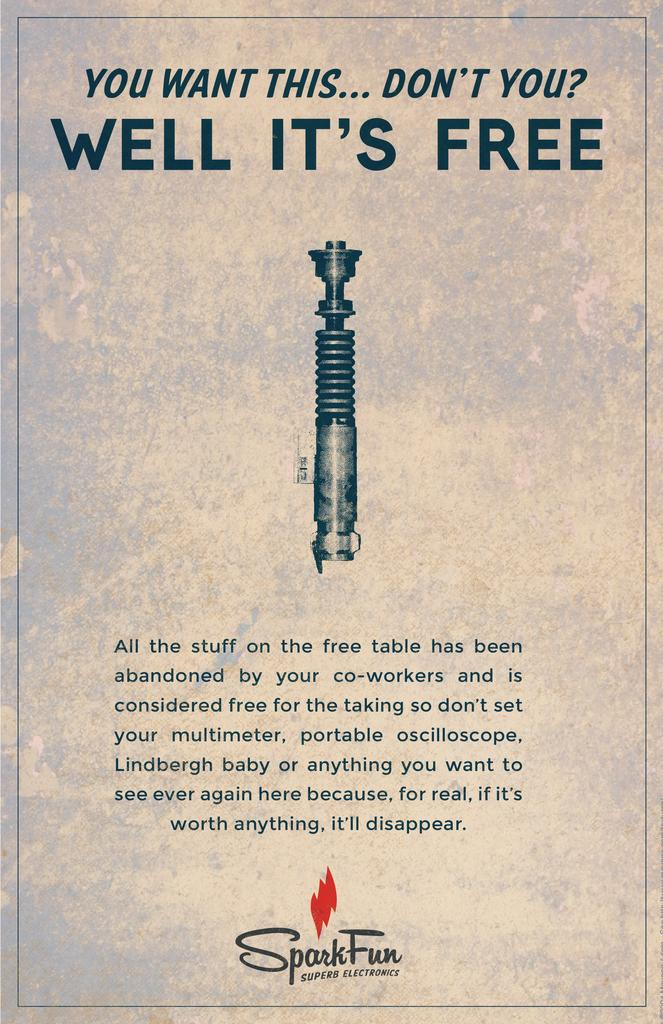<image>
Provide a brief description of the given image. A sign with a  title that says " You Want This... Don't You"?. 